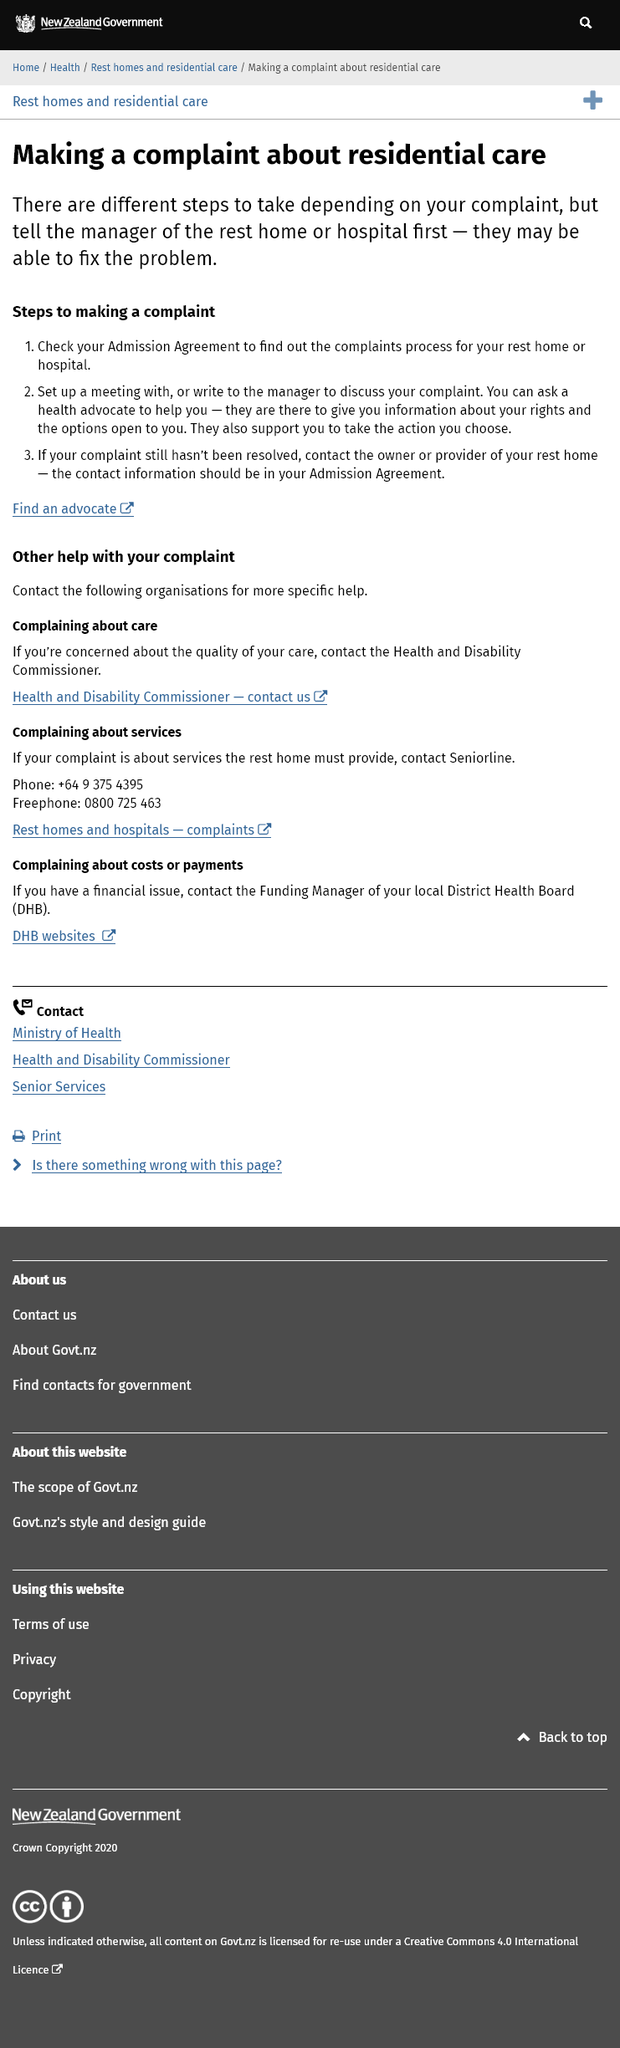Give some essential details in this illustration. Before making a complaint about residential care, it is recommended that you first inform the manager of the rest home or hospital about your concerns. This approach may enable the problem to be resolved without the need for a formal complaint. I am seeking assistance with my complaint as there are advocates and other organizations available to provide support. It is imperative to locate the complaints procedure by consulting the Admission Agreement for the individual rest home or hospital. 